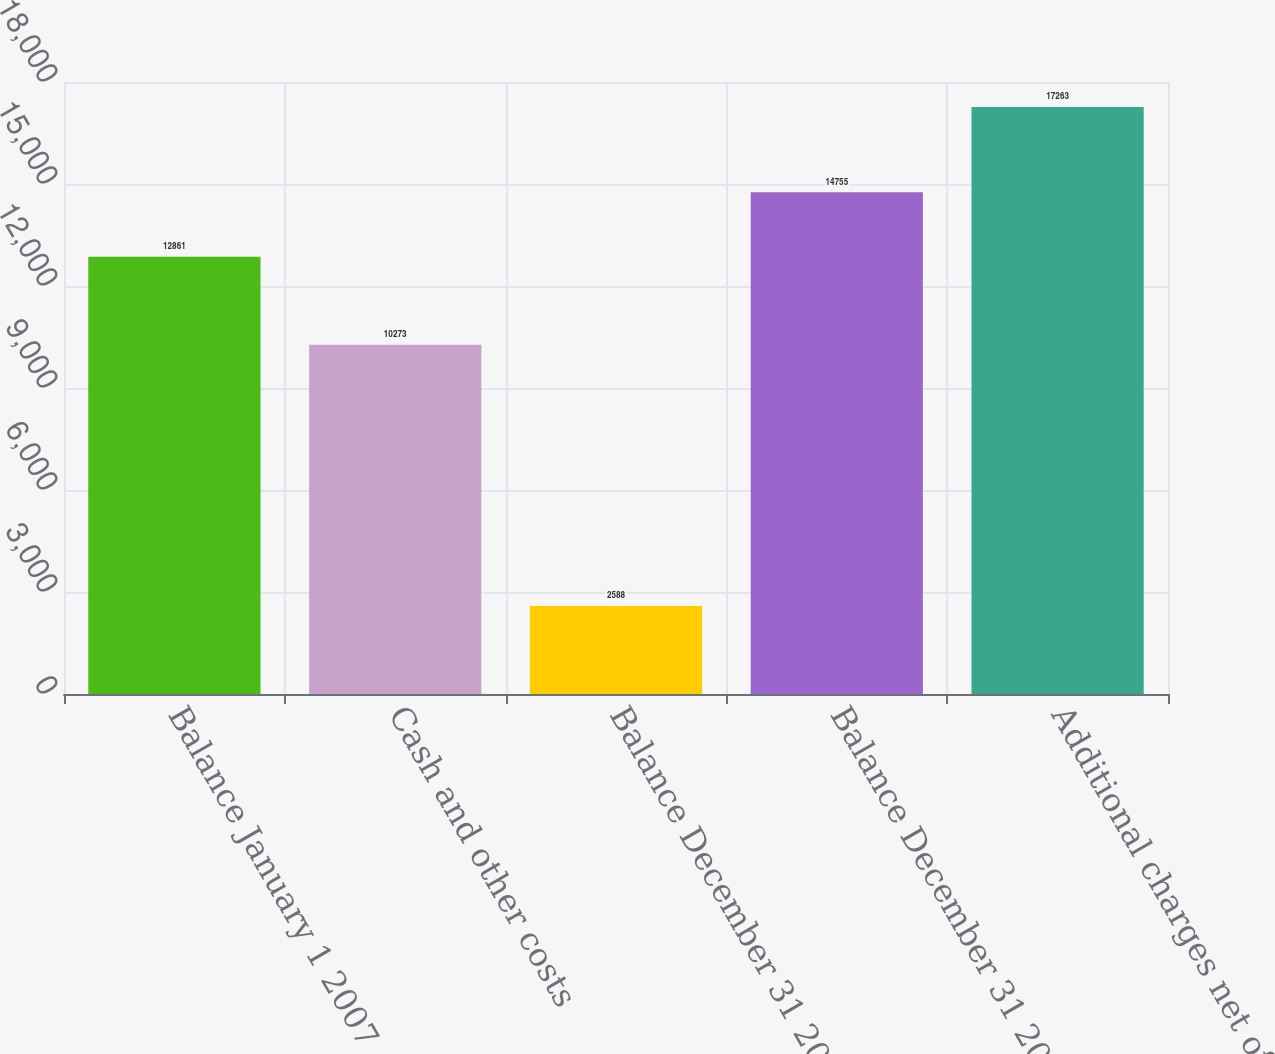<chart> <loc_0><loc_0><loc_500><loc_500><bar_chart><fcel>Balance January 1 2007<fcel>Cash and other costs<fcel>Balance December 31 2007<fcel>Balance December 31 2008<fcel>Additional charges net of<nl><fcel>12861<fcel>10273<fcel>2588<fcel>14755<fcel>17263<nl></chart> 